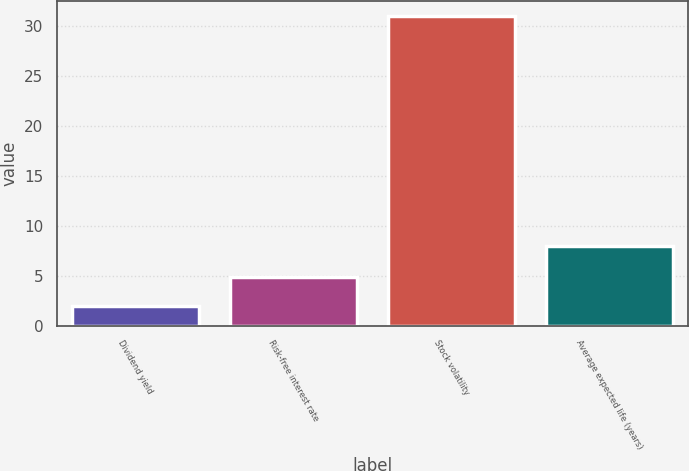<chart> <loc_0><loc_0><loc_500><loc_500><bar_chart><fcel>Dividend yield<fcel>Risk-free interest rate<fcel>Stock volatility<fcel>Average expected life (years)<nl><fcel>2<fcel>4.9<fcel>31<fcel>8<nl></chart> 